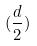<formula> <loc_0><loc_0><loc_500><loc_500>( \frac { d } { 2 } )</formula> 